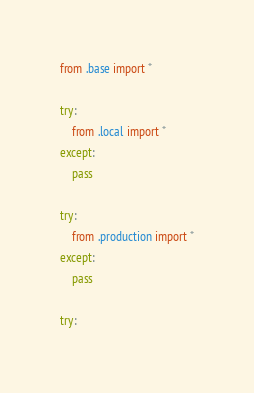Convert code to text. <code><loc_0><loc_0><loc_500><loc_500><_Python_>from .base import *

try:
    from .local import *
except:
    pass

try:
    from .production import *
except:
    pass

try:</code> 